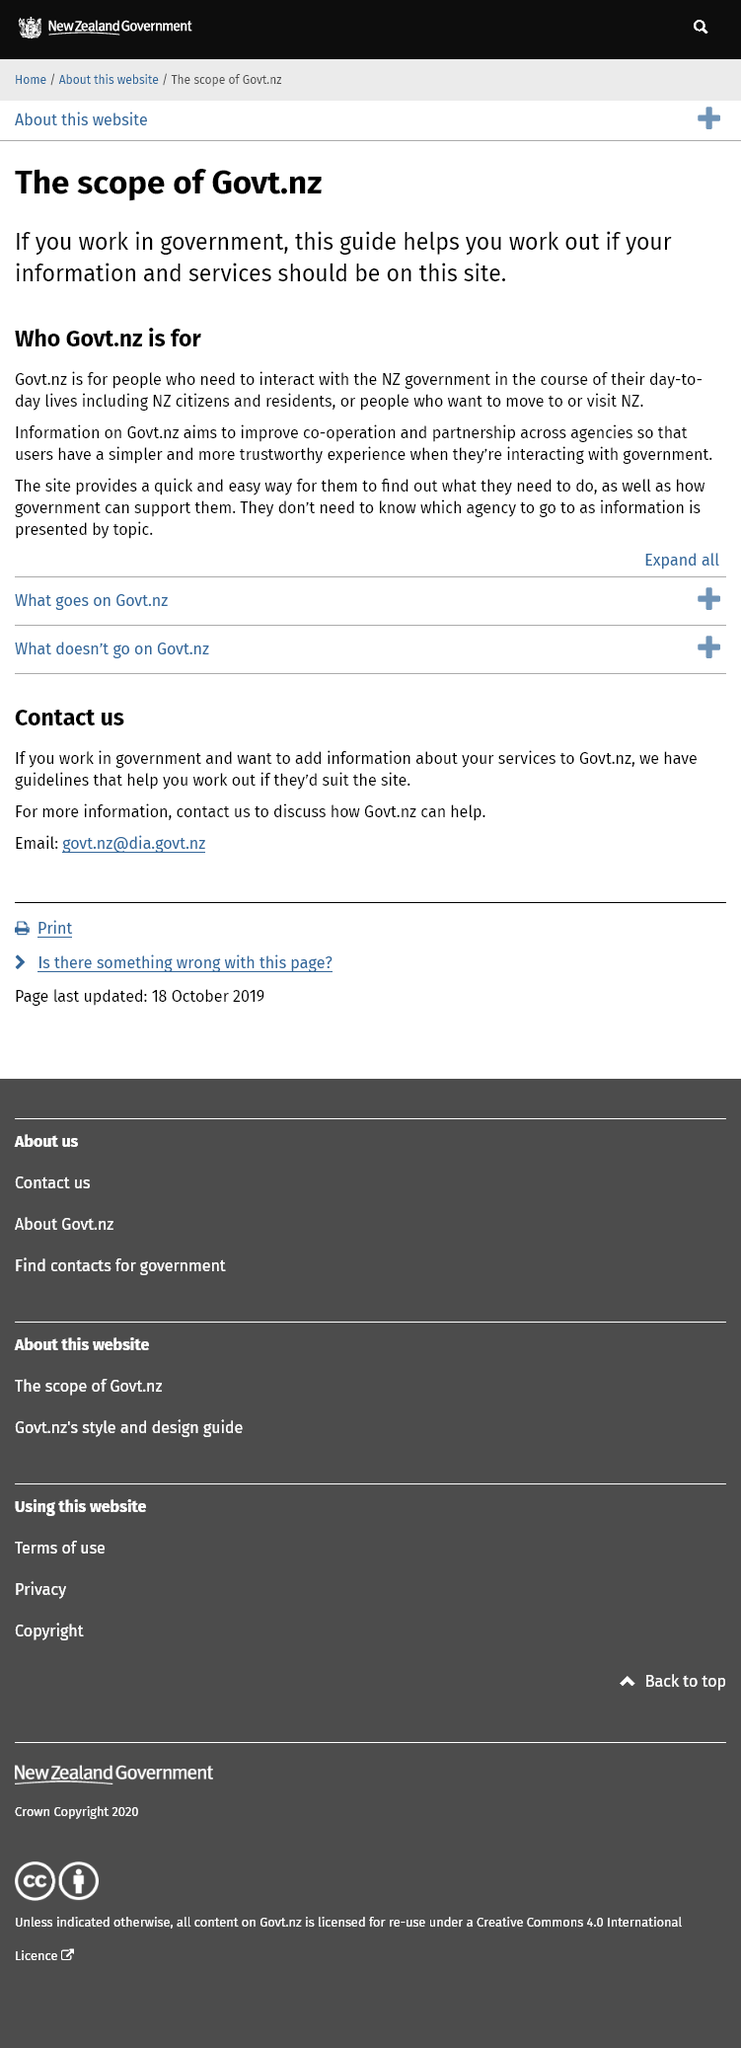Identify some key points in this picture. The government website, Govt.nz, provides a user-friendly platform that enables individuals who wish to move or visit New Zealand to understand the necessary procedures and receive guidance on how the government can assist them in their endeavors. This guide aids individuals in the public sector in determining whether their information and services are appropriate to be featured on this platform. The aim of the information on Govt.nz is to promote cooperation and partnership among government agencies in order to provide users with a simpler and more reliable experience when interacting with the government. 